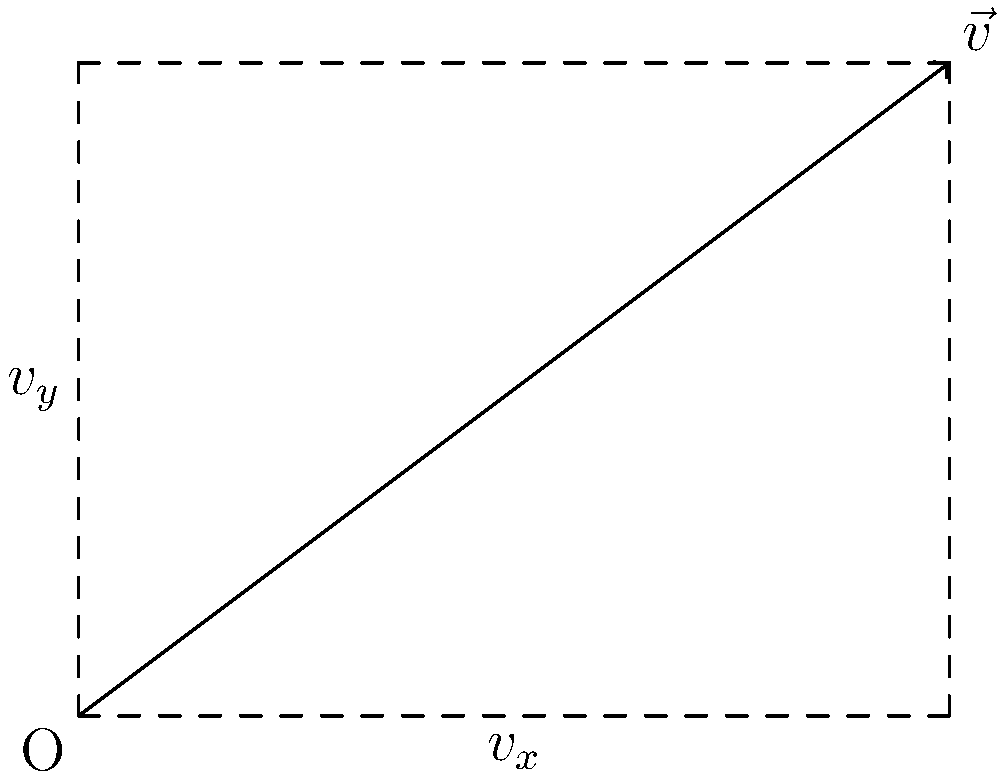In a 2D platform game, a player's movement vector $\vec{v}$ has a magnitude of 5 units and makes a 36.87° angle with the horizontal axis. What are the horizontal ($v_x$) and vertical ($v_y$) components of this vector? To solve this problem, we'll use the trigonometric functions and vector decomposition:

1. Given:
   - Magnitude of $\vec{v}$ = 5 units
   - Angle with horizontal = 36.87°

2. For a vector $\vec{v}$ with magnitude $|\vec{v}|$ and angle $\theta$ with the horizontal:
   - Horizontal component: $v_x = |\vec{v}| \cos(\theta)$
   - Vertical component: $v_y = |\vec{v}| \sin(\theta)$

3. Calculate $v_x$:
   $v_x = 5 \cos(36.87°) \approx 4$ units

4. Calculate $v_y$:
   $v_y = 5 \sin(36.87°) \approx 3$ units

5. Verify using the Pythagorean theorem:
   $|\vec{v}|^2 = v_x^2 + v_y^2$
   $5^2 \approx 4^2 + 3^2$
   $25 \approx 16 + 9 = 25$

The horizontal component $v_x$ is approximately 4 units, and the vertical component $v_y$ is approximately 3 units.
Answer: $v_x \approx 4$ units, $v_y \approx 3$ units 